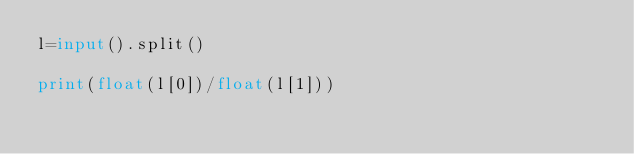Convert code to text. <code><loc_0><loc_0><loc_500><loc_500><_Python_>l=input().split()

print(float(l[0])/float(l[1]))  </code> 